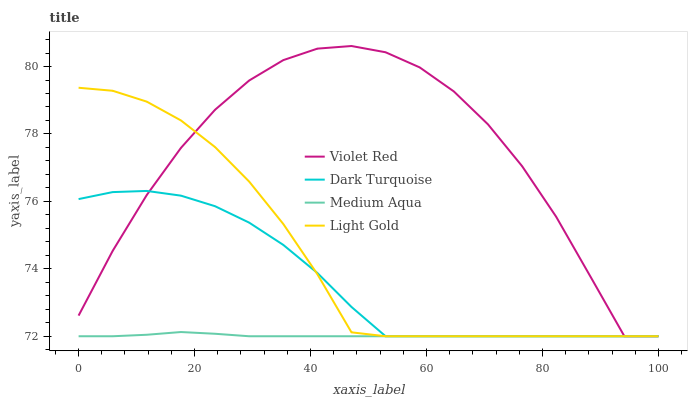Does Light Gold have the minimum area under the curve?
Answer yes or no. No. Does Light Gold have the maximum area under the curve?
Answer yes or no. No. Is Light Gold the smoothest?
Answer yes or no. No. Is Light Gold the roughest?
Answer yes or no. No. Does Light Gold have the highest value?
Answer yes or no. No. 